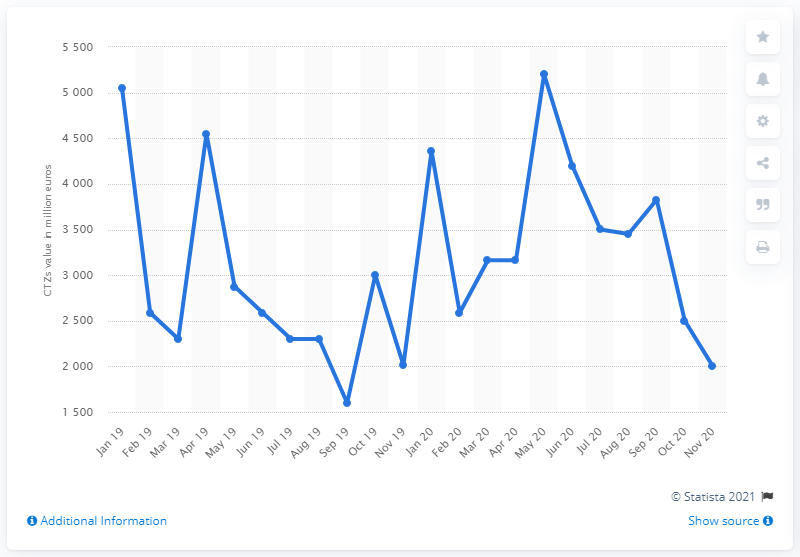Specify some key components in this picture. In May 2020, the highest value of zero-coupon bonds was 5,200. The value of zero-coupon bonds issued by the public administration in Italy as of November 2020 was approximately 5,200. 